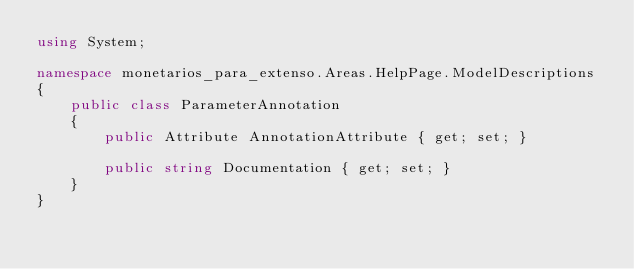Convert code to text. <code><loc_0><loc_0><loc_500><loc_500><_C#_>using System;

namespace monetarios_para_extenso.Areas.HelpPage.ModelDescriptions
{
    public class ParameterAnnotation
    {
        public Attribute AnnotationAttribute { get; set; }

        public string Documentation { get; set; }
    }
}</code> 